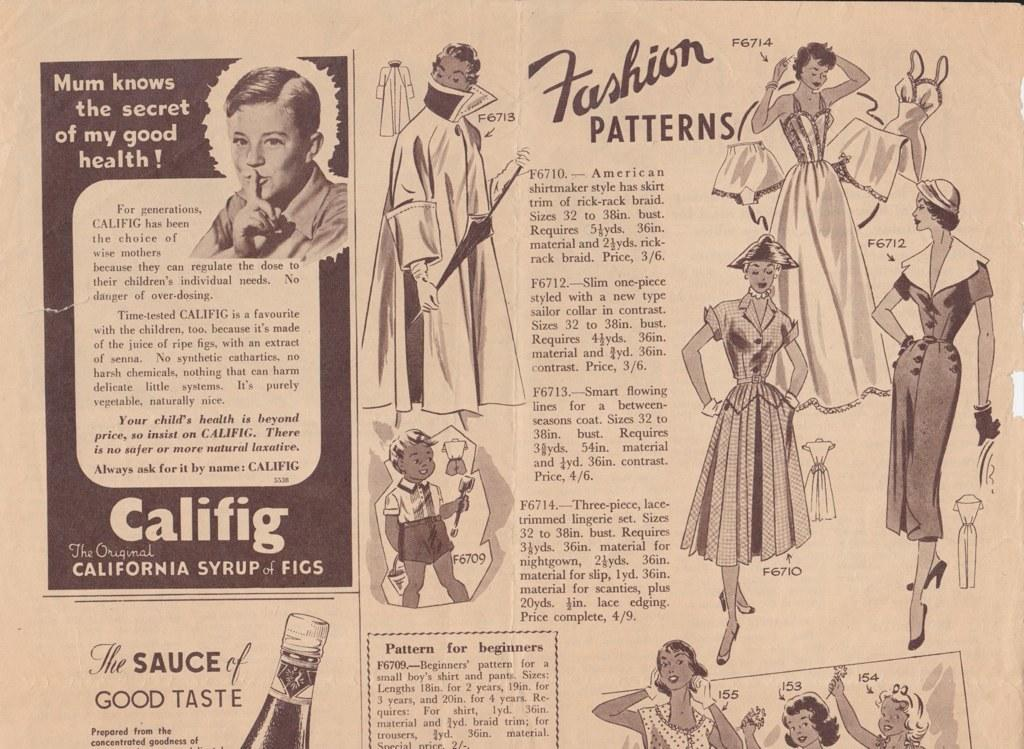What is the main object in the image? There is a newspaper in the image. What type of content can be found in the newspaper? The newspaper contains text. Are there any visual elements in the newspaper? Yes, the newspaper contains pictures of many persons. What type of mask is the person wearing in the image? There is no person wearing a mask in the image; it only contains a newspaper with text and pictures of many persons. What color is the skirt of the person in the image? There is no person wearing a skirt in the image; it only contains a newspaper with text and pictures of many persons. 